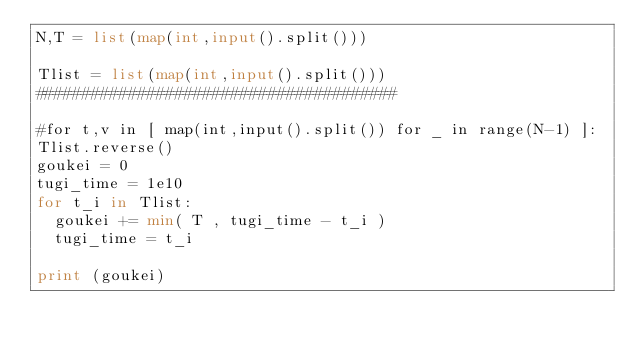<code> <loc_0><loc_0><loc_500><loc_500><_Python_>N,T = list(map(int,input().split()))

Tlist = list(map(int,input().split()))
#######################################

#for t,v in [ map(int,input().split()) for _ in range(N-1) ]:
Tlist.reverse()
goukei = 0
tugi_time = 1e10
for t_i in Tlist:
	goukei += min( T , tugi_time - t_i )
	tugi_time = t_i

print (goukei)</code> 